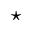Convert formula to latex. <formula><loc_0><loc_0><loc_500><loc_500>^ { * }</formula> 